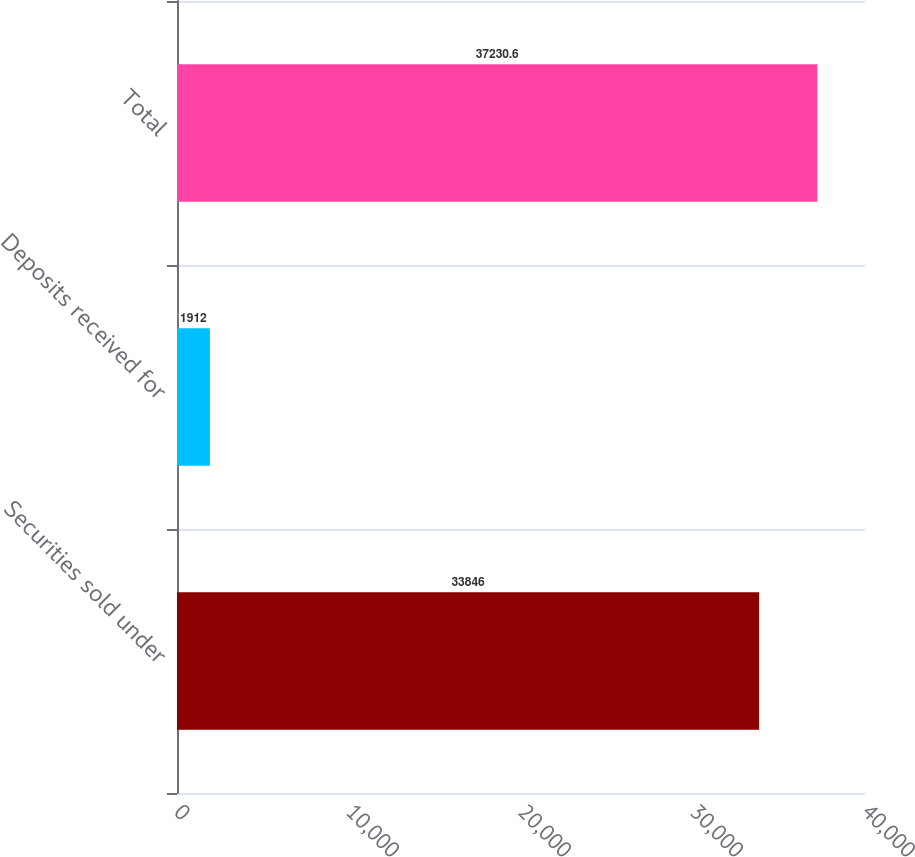<chart> <loc_0><loc_0><loc_500><loc_500><bar_chart><fcel>Securities sold under<fcel>Deposits received for<fcel>Total<nl><fcel>33846<fcel>1912<fcel>37230.6<nl></chart> 